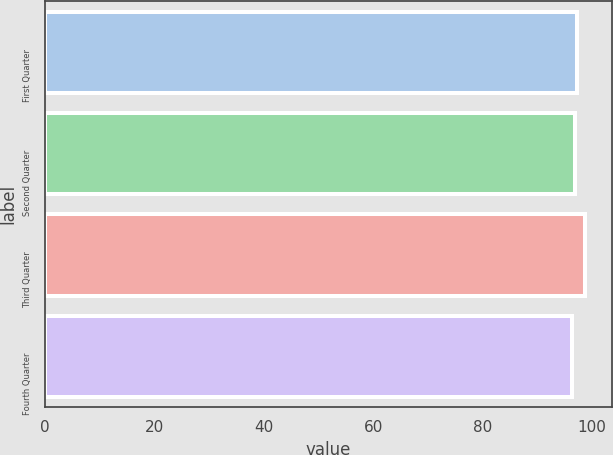Convert chart to OTSL. <chart><loc_0><loc_0><loc_500><loc_500><bar_chart><fcel>First Quarter<fcel>Second Quarter<fcel>Third Quarter<fcel>Fourth Quarter<nl><fcel>97.16<fcel>96.91<fcel>98.69<fcel>96.23<nl></chart> 